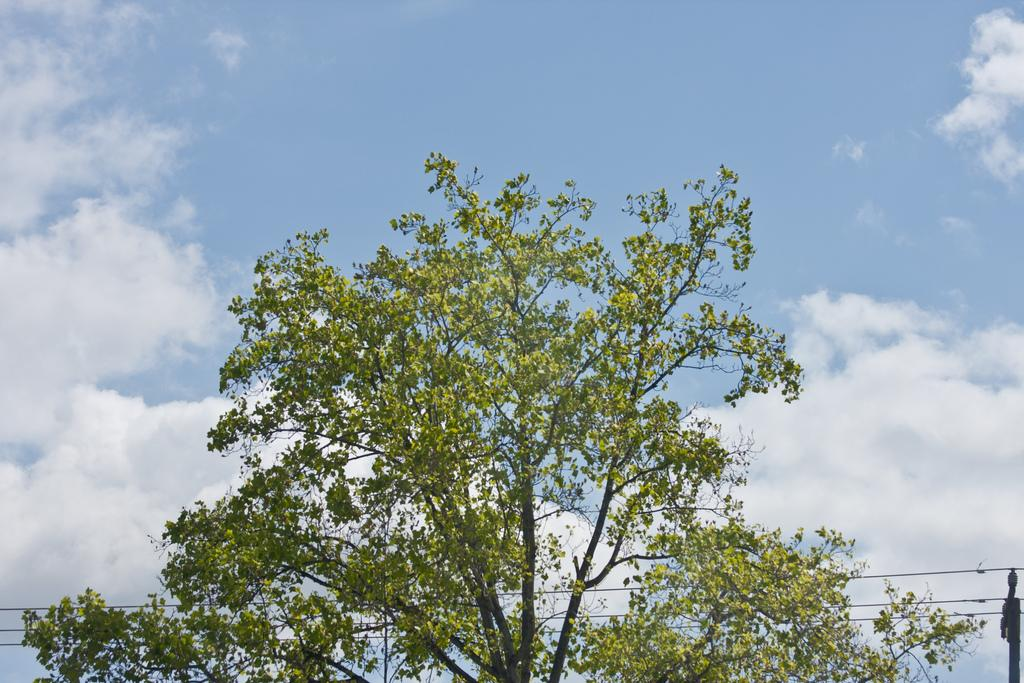What type of natural element is present in the image? There is a tree in the image. What colors can be seen on the tree? The tree is green and black in color. What man-made objects are visible in the image? There are wires and a pole in the image. What can be seen in the background of the image? The sky is visible in the background of the image. What type of drum is being played by the sister in the image? There is no sister or drum present in the image. 